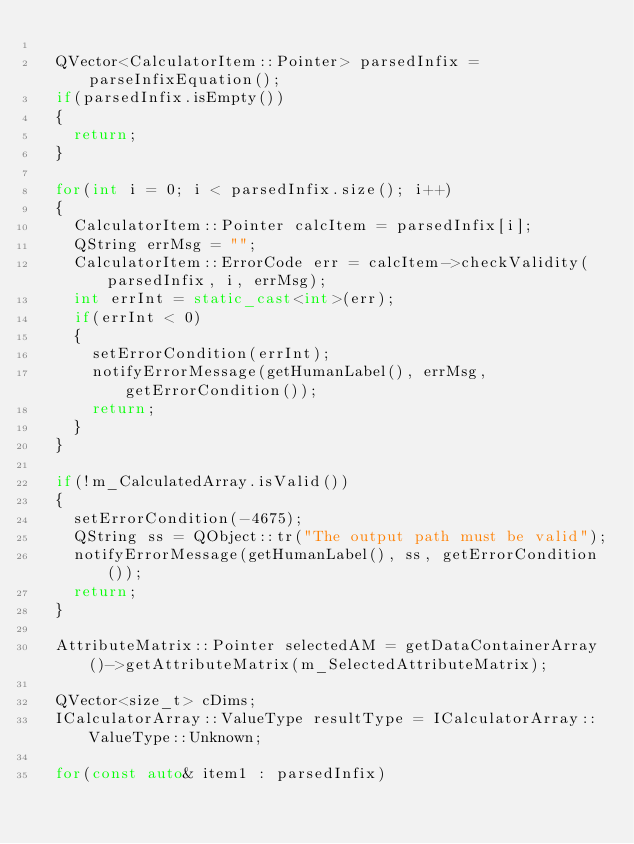<code> <loc_0><loc_0><loc_500><loc_500><_C++_>
  QVector<CalculatorItem::Pointer> parsedInfix = parseInfixEquation();
  if(parsedInfix.isEmpty())
  {
    return;
  }

  for(int i = 0; i < parsedInfix.size(); i++)
  {
    CalculatorItem::Pointer calcItem = parsedInfix[i];
    QString errMsg = "";
    CalculatorItem::ErrorCode err = calcItem->checkValidity(parsedInfix, i, errMsg);
    int errInt = static_cast<int>(err);
    if(errInt < 0)
    {
      setErrorCondition(errInt);
      notifyErrorMessage(getHumanLabel(), errMsg, getErrorCondition());
      return;
    }
  }

  if(!m_CalculatedArray.isValid())
  {
    setErrorCondition(-4675);
    QString ss = QObject::tr("The output path must be valid");
    notifyErrorMessage(getHumanLabel(), ss, getErrorCondition());
    return;
  }

  AttributeMatrix::Pointer selectedAM = getDataContainerArray()->getAttributeMatrix(m_SelectedAttributeMatrix);

  QVector<size_t> cDims;
  ICalculatorArray::ValueType resultType = ICalculatorArray::ValueType::Unknown;

  for(const auto& item1 : parsedInfix)</code> 